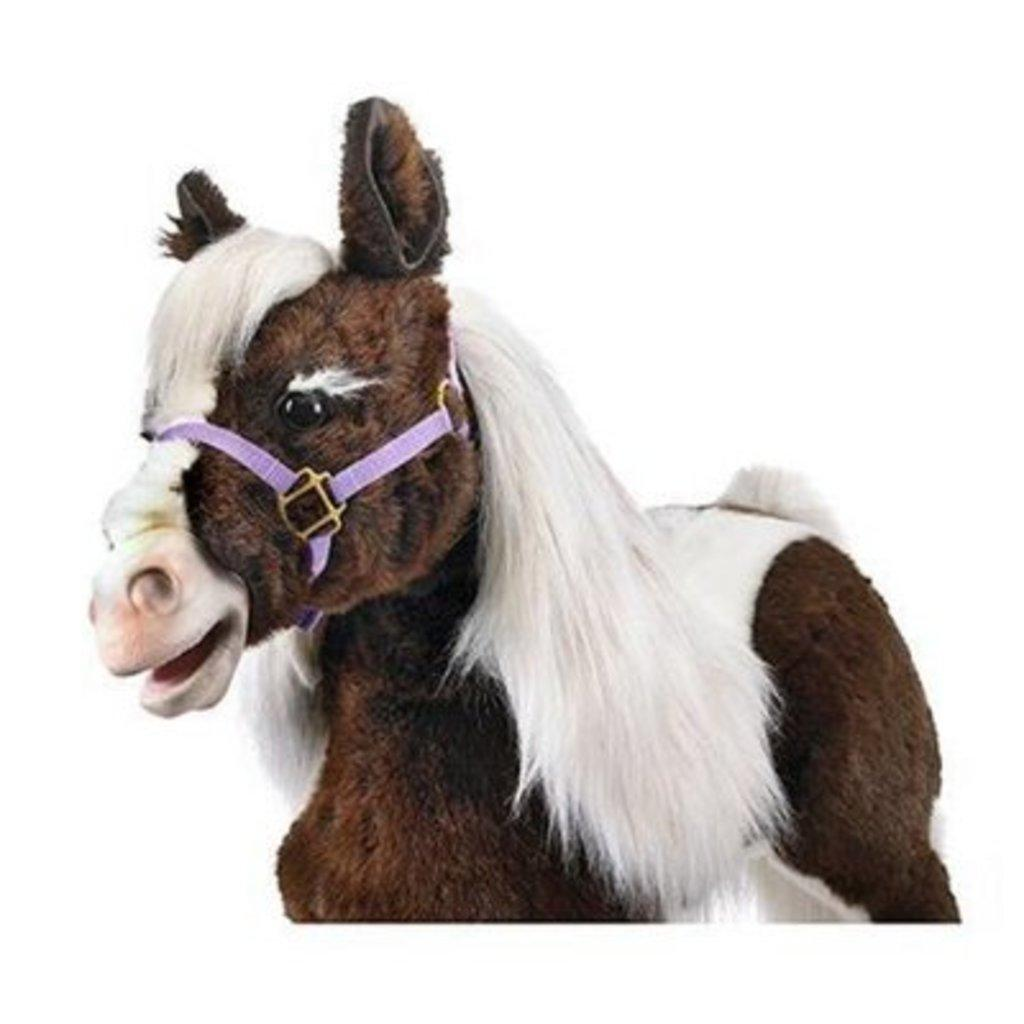What type of toy is present in the image? There is a toy horse in the image. Can you describe the toy in more detail? The toy horse is likely made of plastic or another material and is designed to resemble a real horse. What might a child do with the toy horse? A child might play with the toy horse, using it to create imaginative scenarios or to learn about horses. What type of seed is visible on the toy horse in the image? There is no seed present on the toy horse in the image. How does the toy horse help with a cough in the image? The toy horse does not have any direct impact on a cough, as it is an inanimate object and not a medical treatment. 